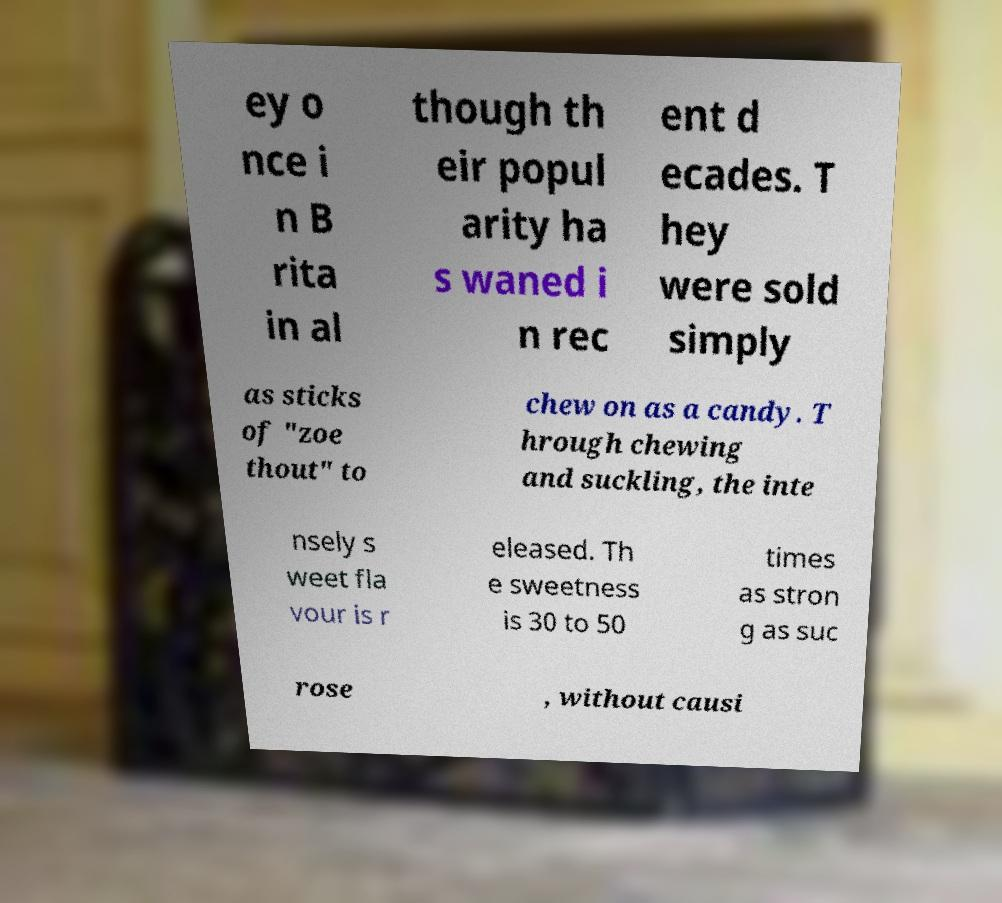I need the written content from this picture converted into text. Can you do that? ey o nce i n B rita in al though th eir popul arity ha s waned i n rec ent d ecades. T hey were sold simply as sticks of "zoe thout" to chew on as a candy. T hrough chewing and suckling, the inte nsely s weet fla vour is r eleased. Th e sweetness is 30 to 50 times as stron g as suc rose , without causi 